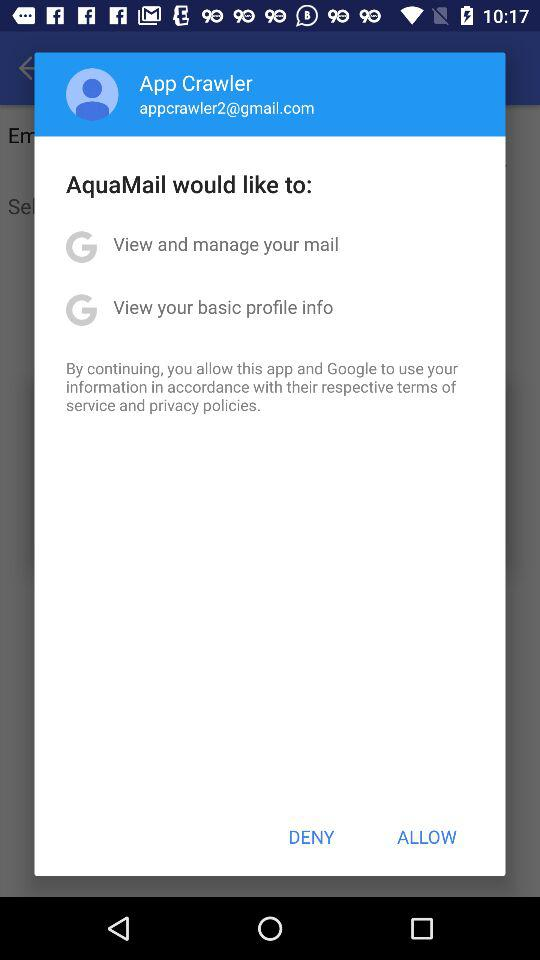How many permissions are requested?
Answer the question using a single word or phrase. 2 